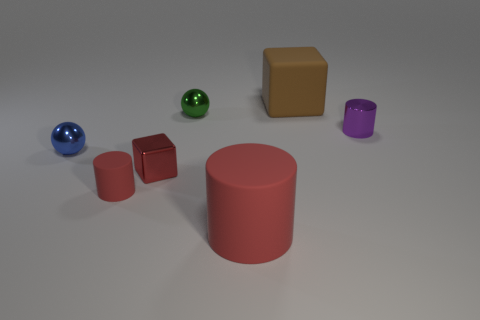Is the number of cubes greater than the number of big red rubber things?
Provide a succinct answer. Yes. The matte thing behind the shiny object that is to the right of the rubber object that is to the right of the large red matte cylinder is what color?
Keep it short and to the point. Brown. There is a block that is made of the same material as the small blue thing; what color is it?
Ensure brevity in your answer.  Red. How many objects are large objects behind the metallic cylinder or small things that are behind the tiny rubber cylinder?
Your answer should be compact. 5. There is a red matte object that is right of the metallic block; is its size the same as the matte thing that is to the right of the big matte cylinder?
Give a very brief answer. Yes. There is another big matte object that is the same shape as the purple object; what color is it?
Provide a short and direct response. Red. Is the number of red cylinders on the right side of the tiny red matte cylinder greater than the number of big brown blocks that are right of the tiny metal cylinder?
Ensure brevity in your answer.  Yes. What is the size of the matte thing that is behind the small red cylinder in front of the small red shiny object that is to the left of the large red rubber thing?
Your answer should be very brief. Large. Is the large brown block made of the same material as the red cylinder that is behind the big rubber cylinder?
Your answer should be compact. Yes. Is the shape of the purple object the same as the big red rubber object?
Your response must be concise. Yes. 